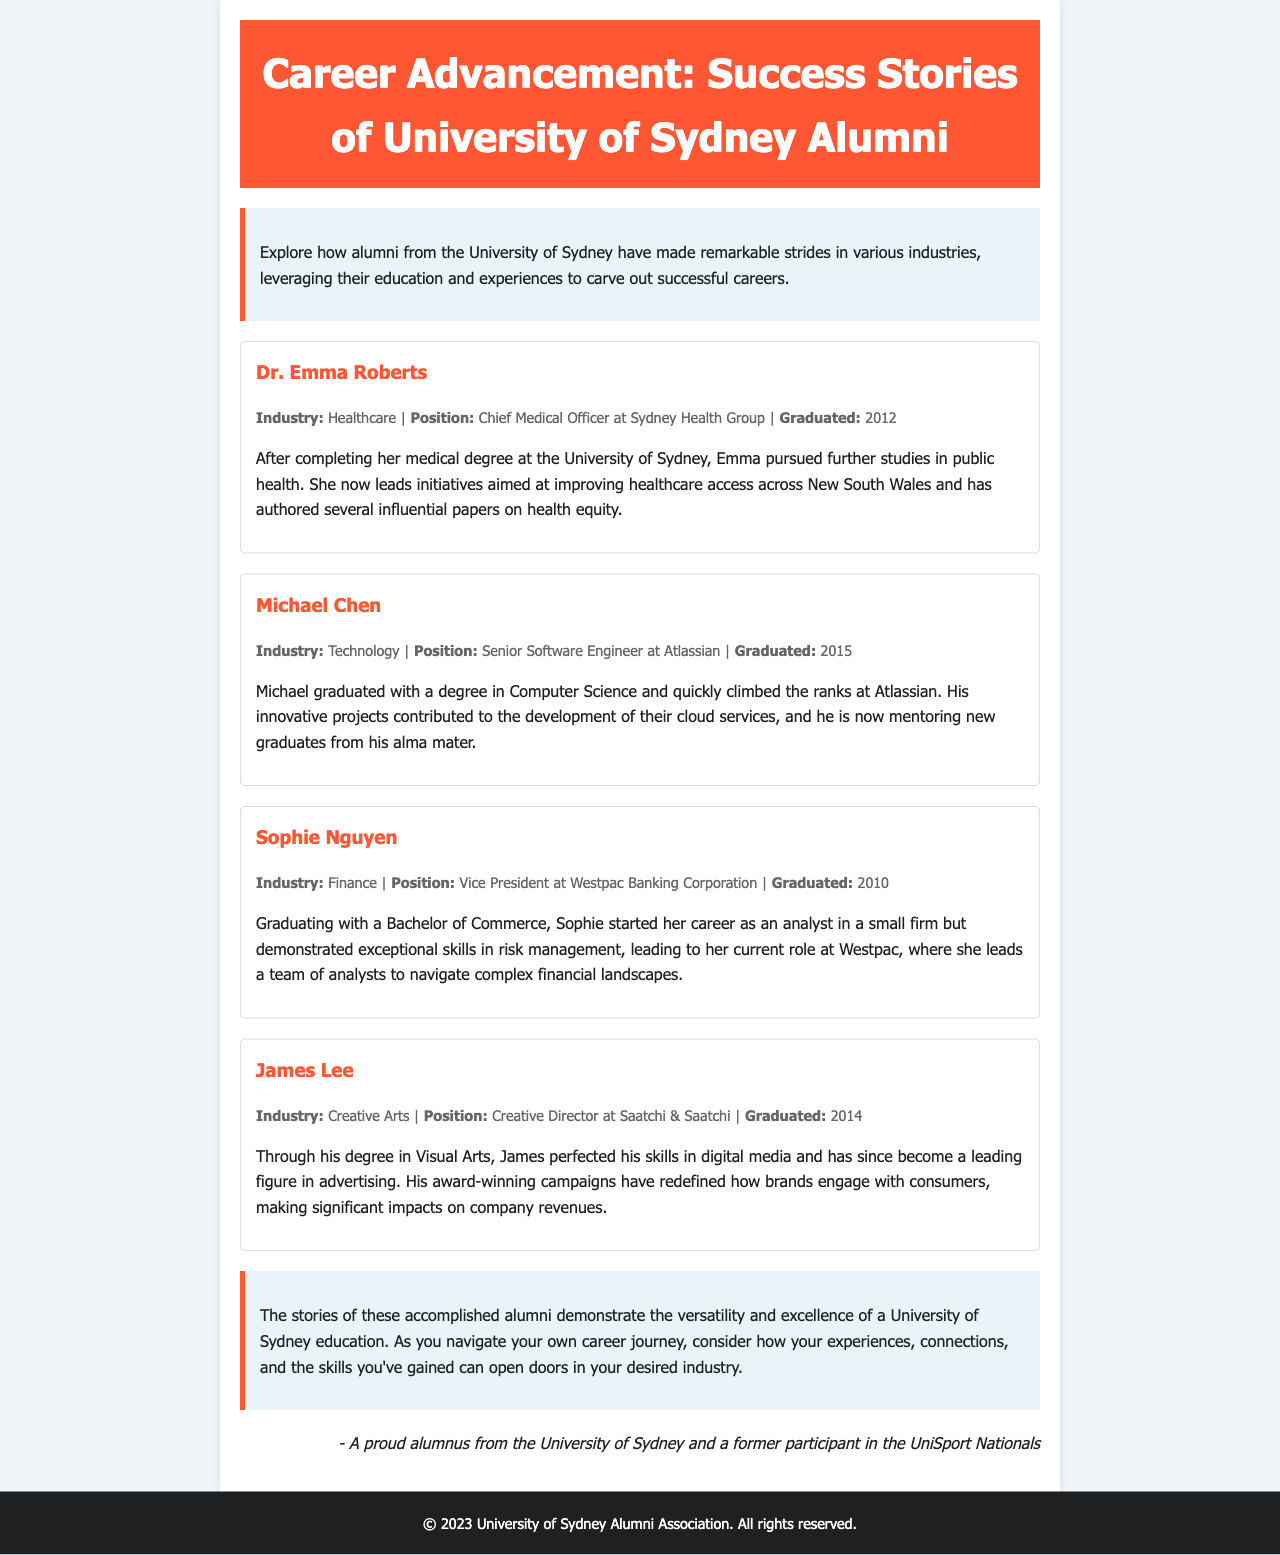What is the title of the newsletter? The title is presented prominently at the top of the document.
Answer: Career Advancement: Success Stories of University of Sydney Alumni Who is the Chief Medical Officer at Sydney Health Group? The document identifies the person in this position within the healthcare industry.
Answer: Dr. Emma Roberts In which year did Michael Chen graduate? The graduation year is specified in the details of the success story.
Answer: 2015 What position does Sophie Nguyen hold at Westpac Banking Corporation? The document provides details on Sophie's career advancement in the finance sector.
Answer: Vice President What degree did James Lee graduate with? The document notes the academic qualifications relevant to each alumnus’ story.
Answer: Visual Arts Which industry does Dr. Emma Roberts work in? The document classifies Dr. Roberts' success story under a specific industry.
Answer: Healthcare What type of projects has Michael Chen contributed to at Atlassian? The document highlights Michael's work and contributions in the technology sector.
Answer: Cloud services What is the primary focus of the success stories in the newsletter? The document introduces the main theme and focus of the highlighted alumni stories.
Answer: Career advancement How does the document describe the versatility of a University of Sydney education? The conclusion section encapsulates the overall message about the education received at the university.
Answer: Demonstrates versatility and excellence 